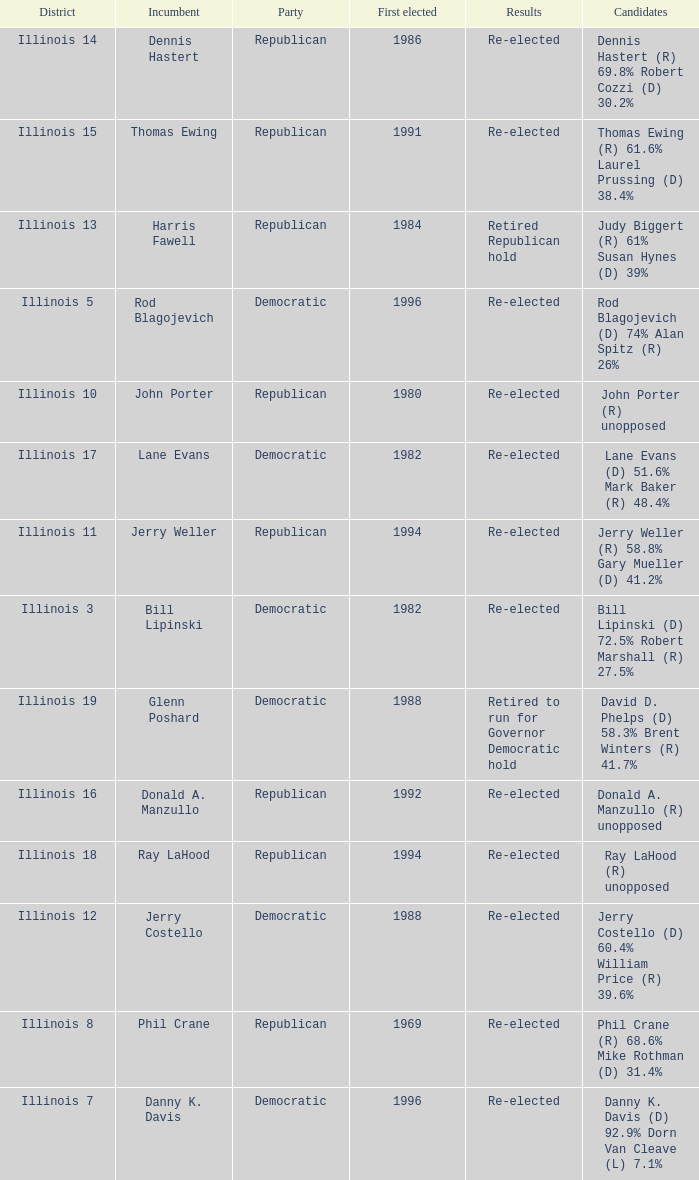What district was John Porter elected in? Illinois 10. 